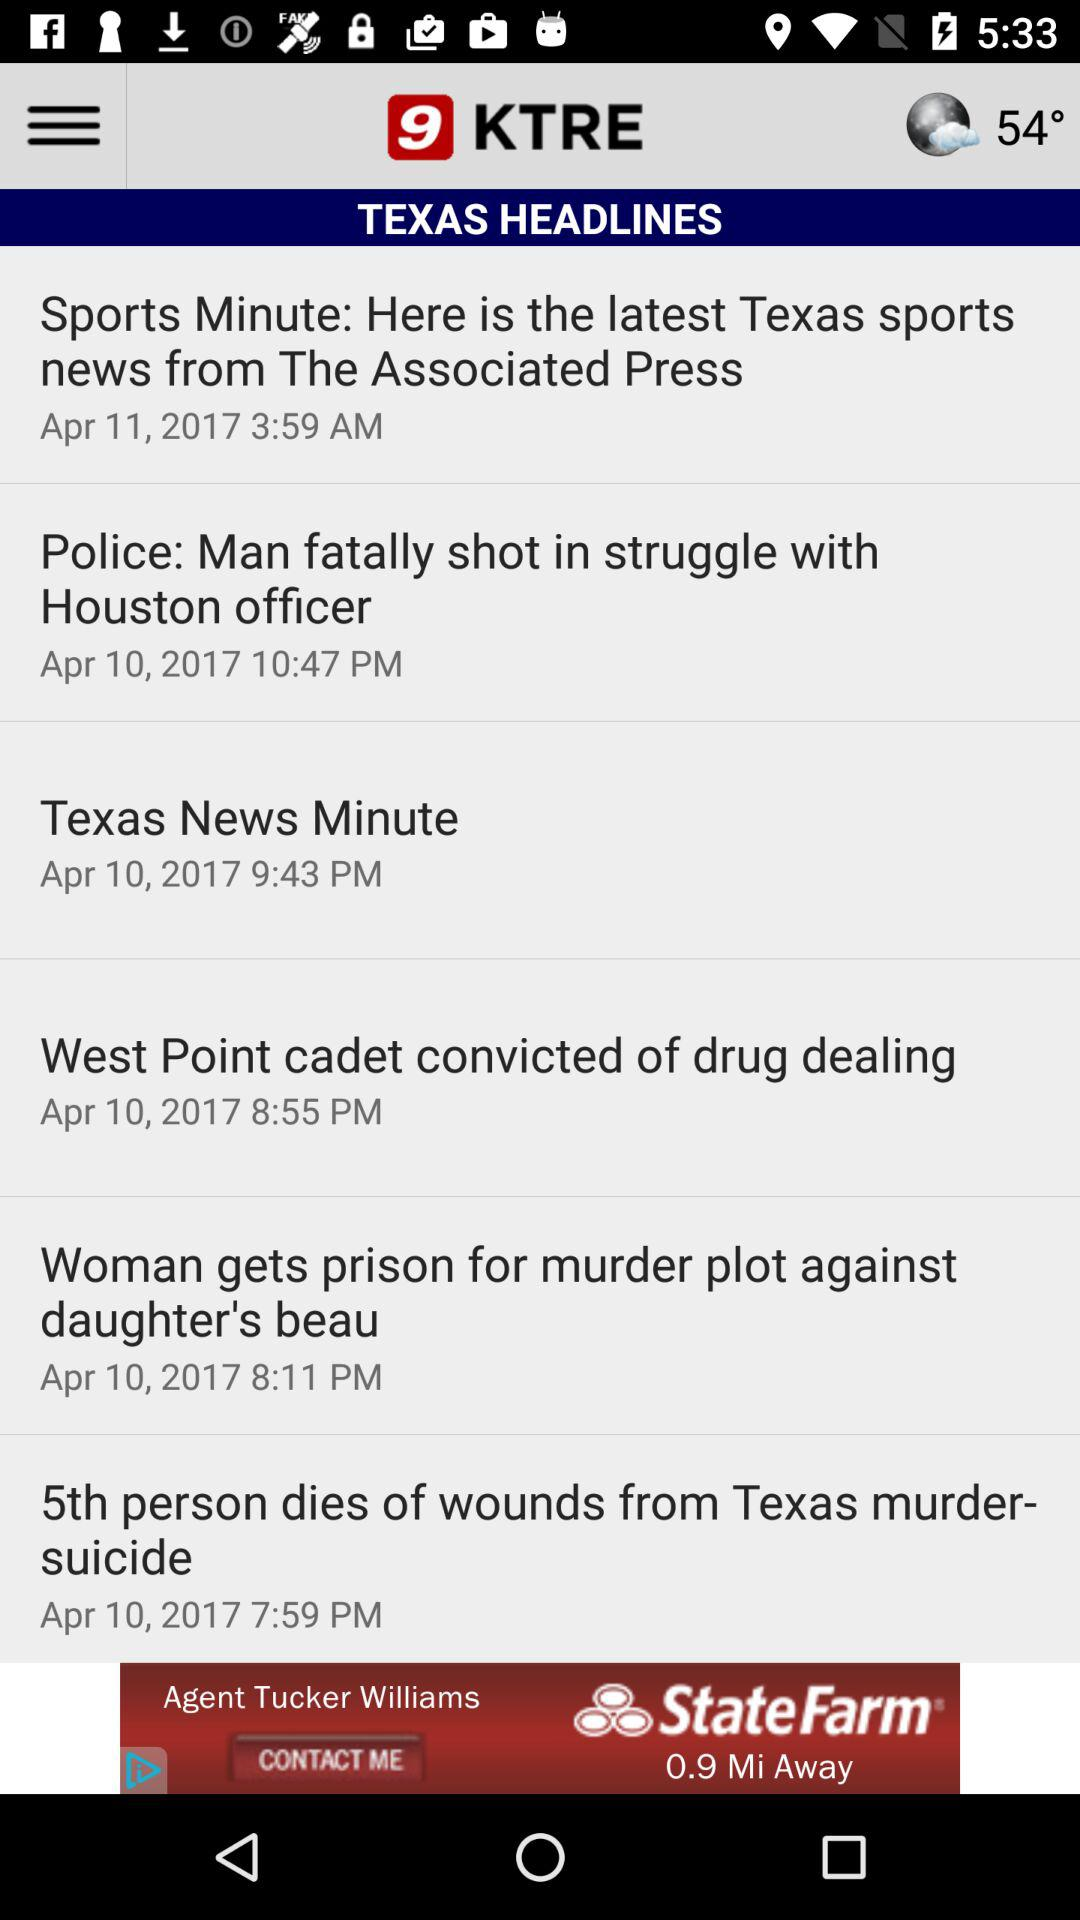Which headline was published on April 11, 2017? The headline "Sports Minute: Here is the latest Texas sports news from The Associated Press" was published on April 11, 2017. 